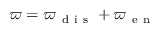Convert formula to latex. <formula><loc_0><loc_0><loc_500><loc_500>\varpi = \varpi _ { d i s } + \varpi _ { e n }</formula> 